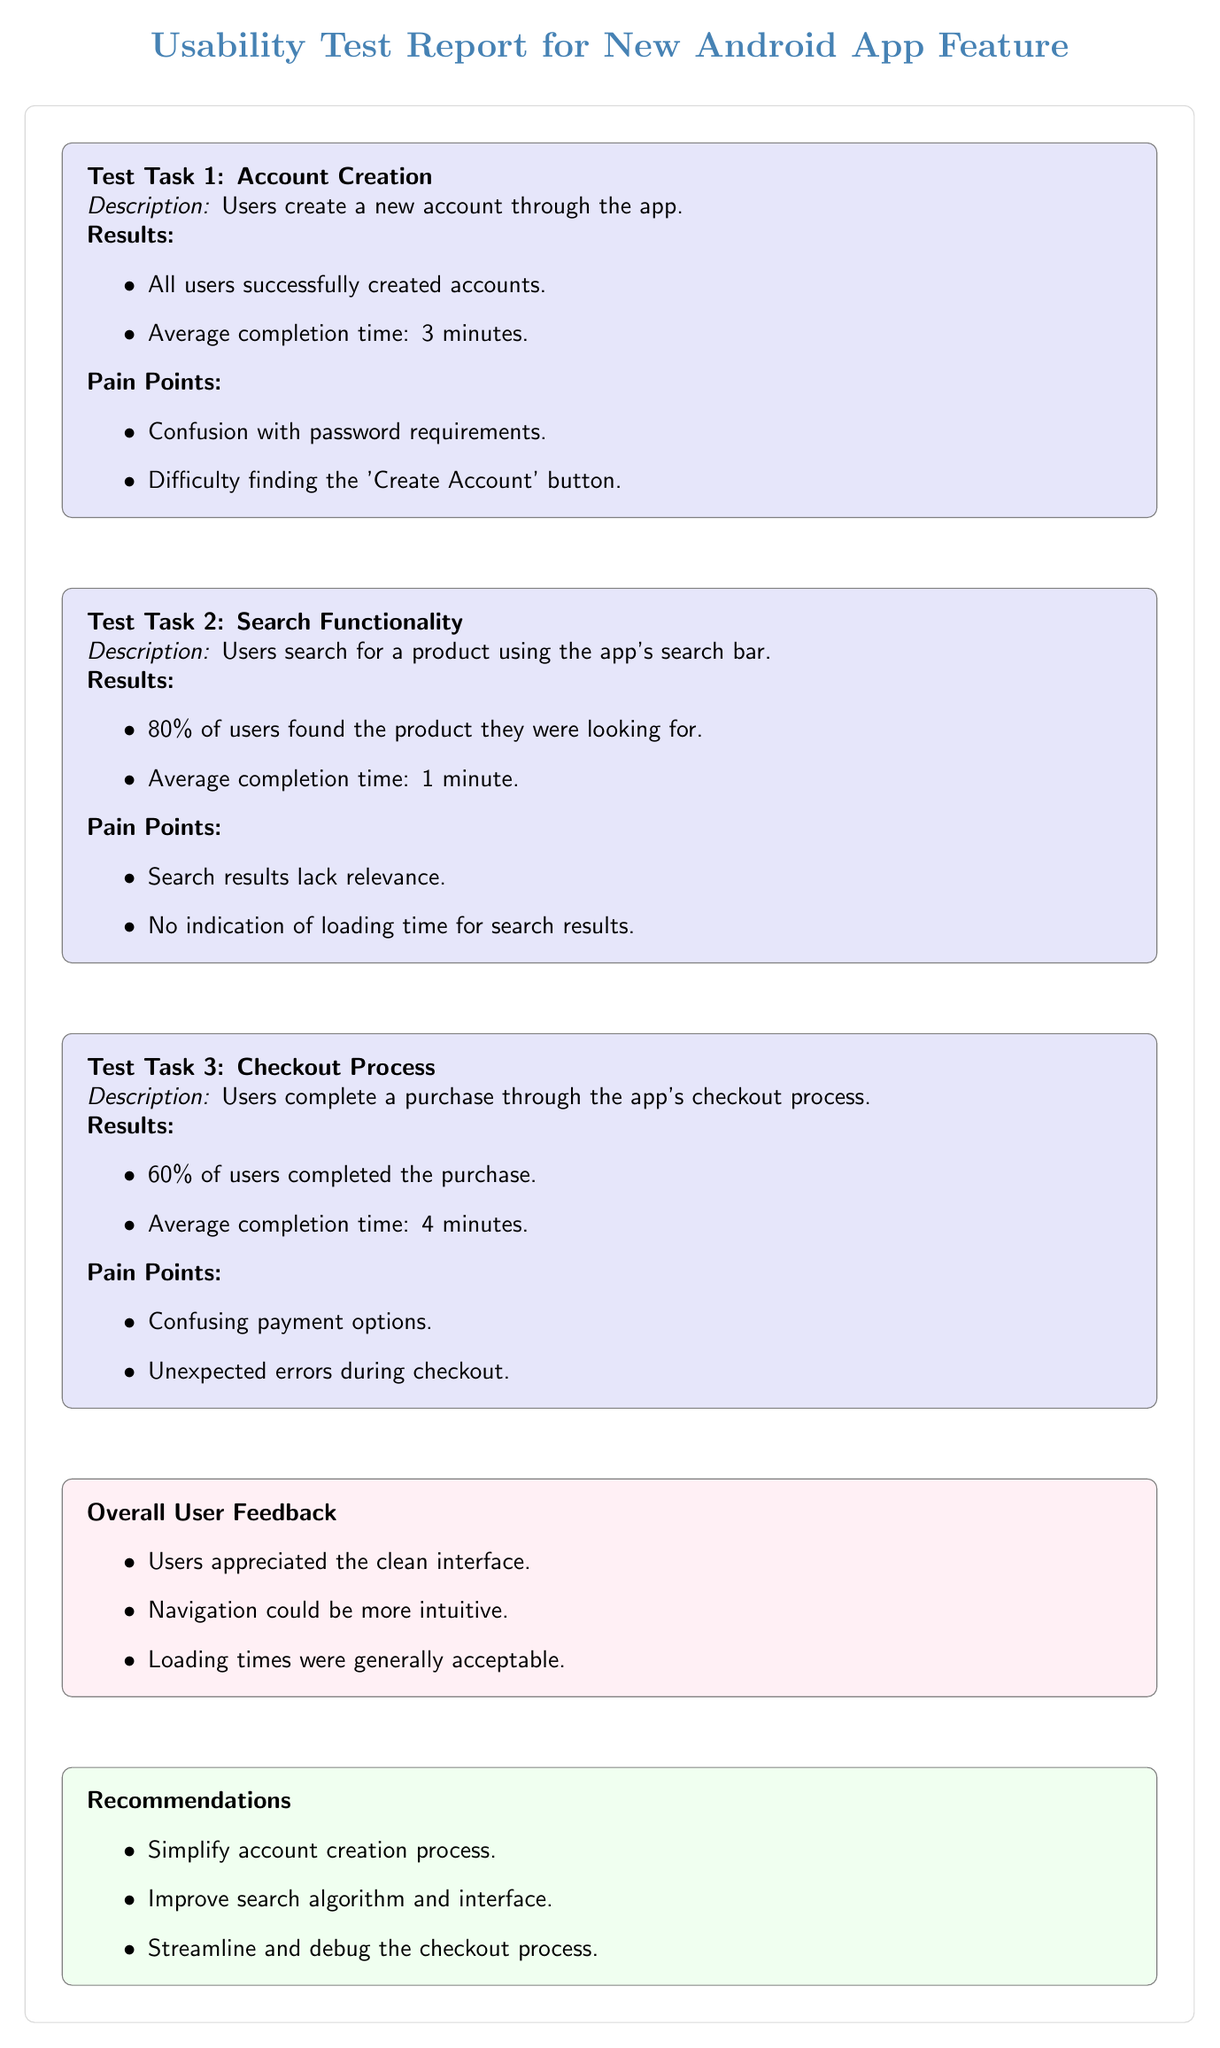What is the average completion time for the account creation task? The average completion time for the account creation task is directly noted under the results section for Test Task 1, which states "Average completion time: 3 minutes." Thus, it can be directly retrieved from this specified location.
Answer: 3 minutes How many test tasks are included in the report? The diagram contains three clearly separated test tasks as indicated by the labels "Test Task 1," "Test Task 2," and "Test Task 3." Counting these labeled sections gives a total of three tasks.
Answer: 3 What percentage of users completed the purchase during the checkout process? This information is provided in the results section of Test Task 3, which states "60% of users completed the purchase." By referencing this specific part of the diagram, we can determine the exact percentage.
Answer: 60% What are the two pain points listed for the search functionality? The pain points for search functionality are detailed under the "Pain Points" subsection of Test Task 2. They are specifically stated as "Search results lack relevance" and "No indication of loading time for search results." These points are explicitly laid out, allowing for a straightforward extraction of this information.
Answer: Search results lack relevance; No indication of loading time for search results What was the average completion time for the checkout process? The average completion time is listed under the results of Test Task 3, which states "Average completion time: 4 minutes." By referring to this section, the exact figure can be obtained.
Answer: 4 minutes How many users found the product they were searching for? According to the results section for Test Task 2, "80% of users found the product they were looking for." This percentage conveys the success rate and can be directly interpreted from that specific node.
Answer: 80% What recommendation is made regarding the account creation process? The recommendations are summarized in the "Recommendations" section below the overall user feedback. The specific recommendation for the account creation process is clearly stated as "Simplify account creation process." This wording can be directly lifted from the diagram's content.
Answer: Simplify account creation process Which test task had the highest reported average completion time? By comparing the average completion times listed for each task, we find that Task 1 reports "3 minutes," Task 2 reports "1 minute," and Task 3 reports "4 minutes." The highest of these values is 4 minutes from the checkout process (Test Task 3). This comparison leads to the conclusion.
Answer: Checkout process (4 minutes) 